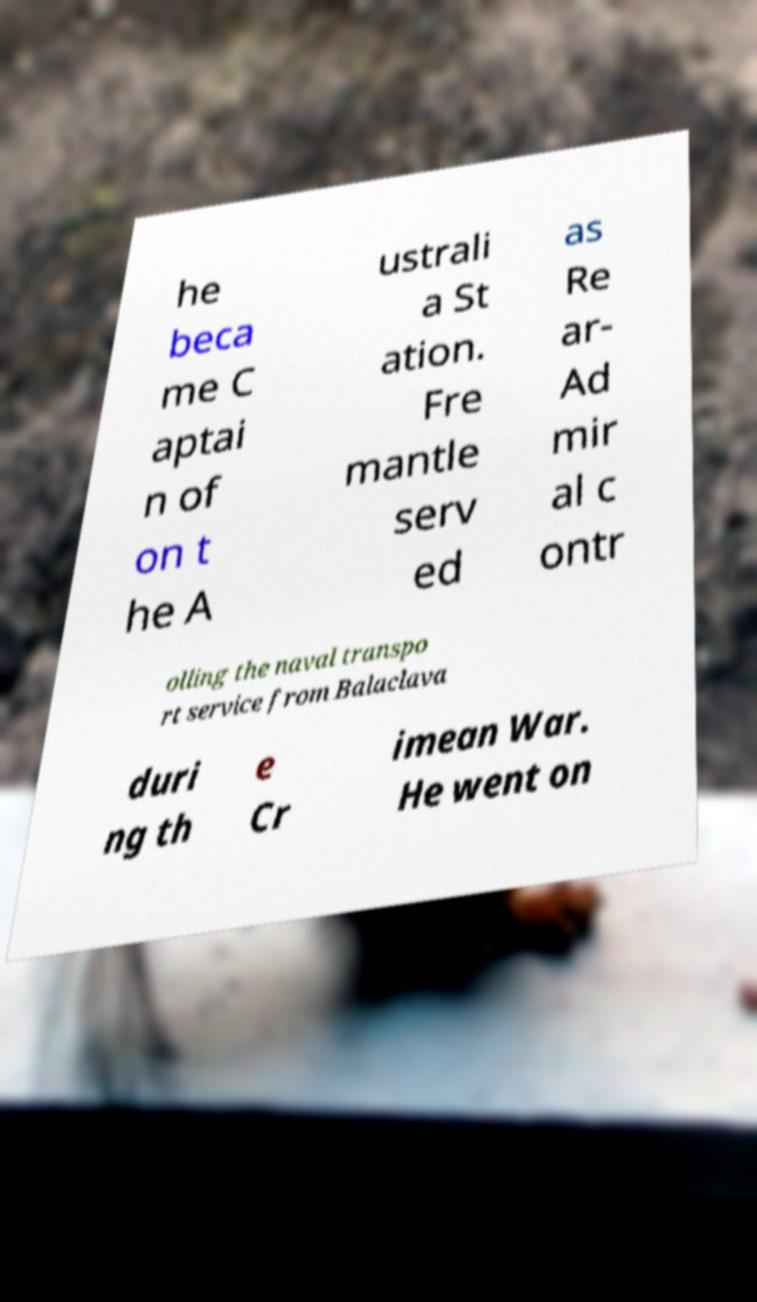Can you accurately transcribe the text from the provided image for me? he beca me C aptai n of on t he A ustrali a St ation. Fre mantle serv ed as Re ar- Ad mir al c ontr olling the naval transpo rt service from Balaclava duri ng th e Cr imean War. He went on 